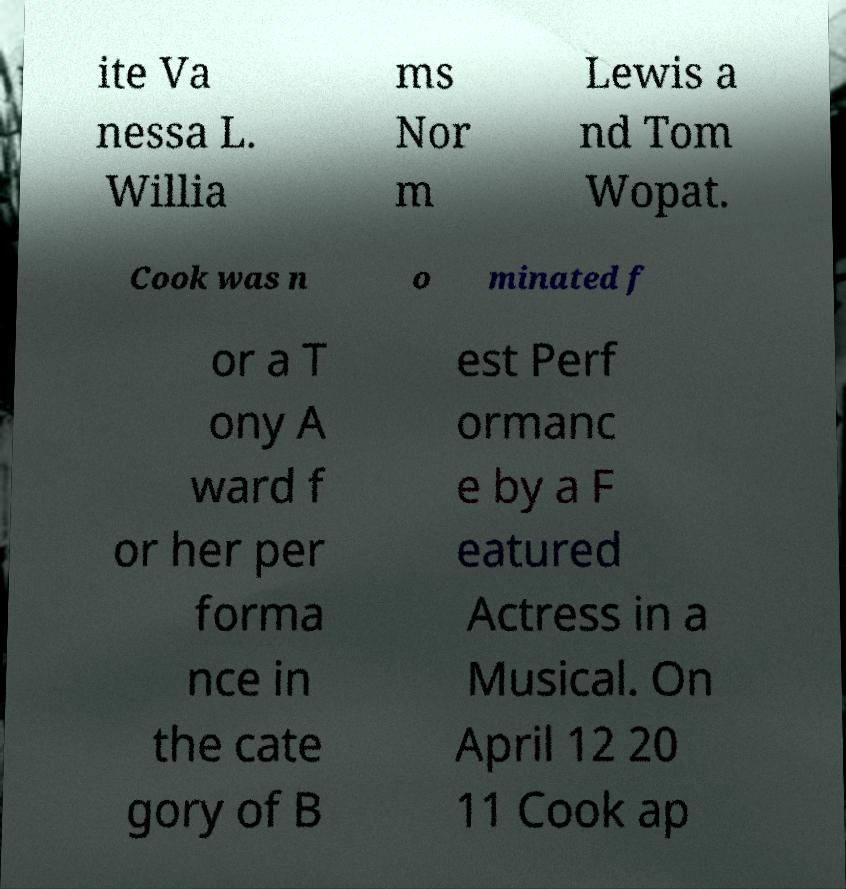Could you extract and type out the text from this image? ite Va nessa L. Willia ms Nor m Lewis a nd Tom Wopat. Cook was n o minated f or a T ony A ward f or her per forma nce in the cate gory of B est Perf ormanc e by a F eatured Actress in a Musical. On April 12 20 11 Cook ap 